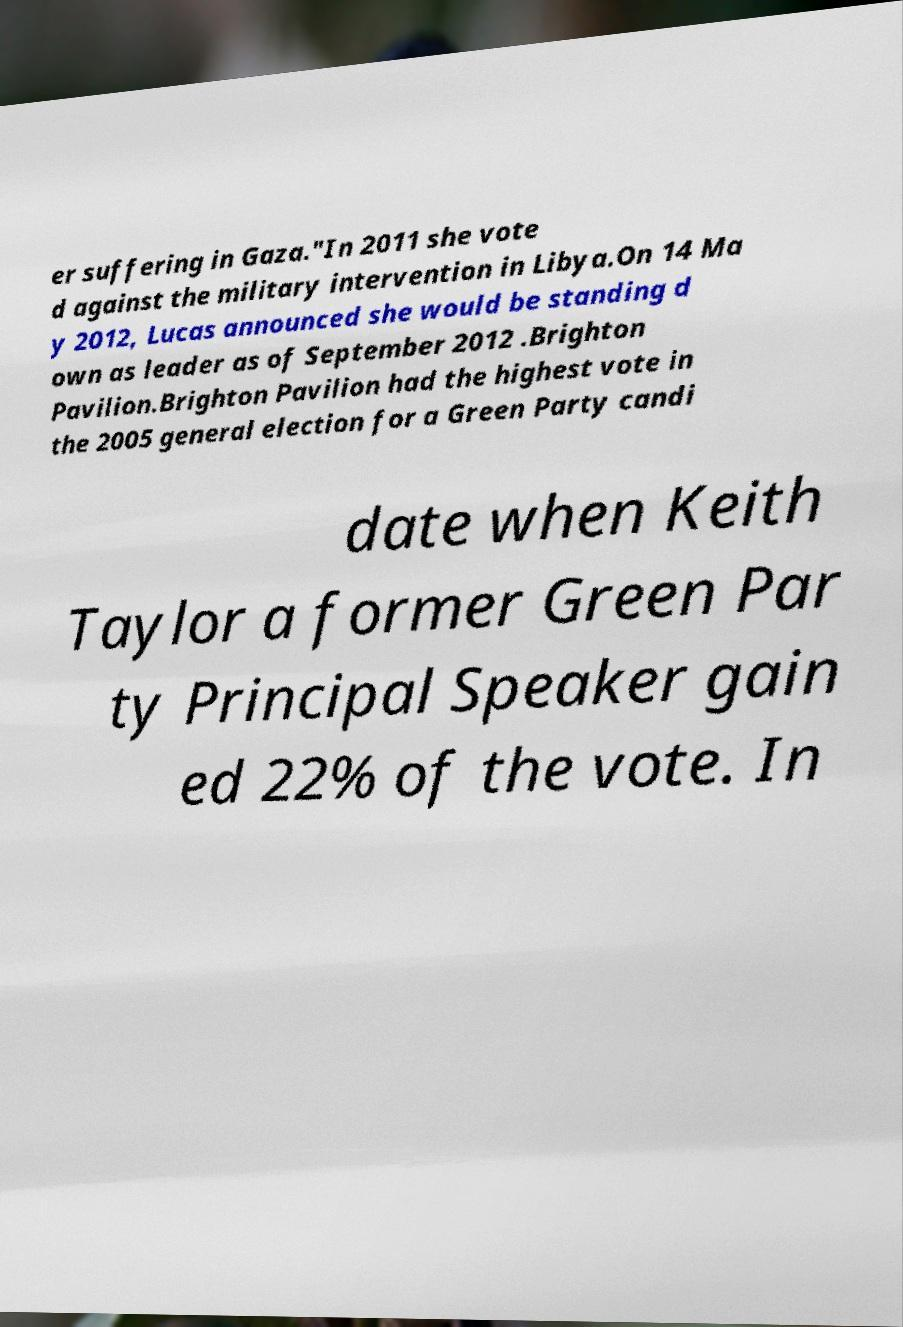There's text embedded in this image that I need extracted. Can you transcribe it verbatim? er suffering in Gaza."In 2011 she vote d against the military intervention in Libya.On 14 Ma y 2012, Lucas announced she would be standing d own as leader as of September 2012 .Brighton Pavilion.Brighton Pavilion had the highest vote in the 2005 general election for a Green Party candi date when Keith Taylor a former Green Par ty Principal Speaker gain ed 22% of the vote. In 